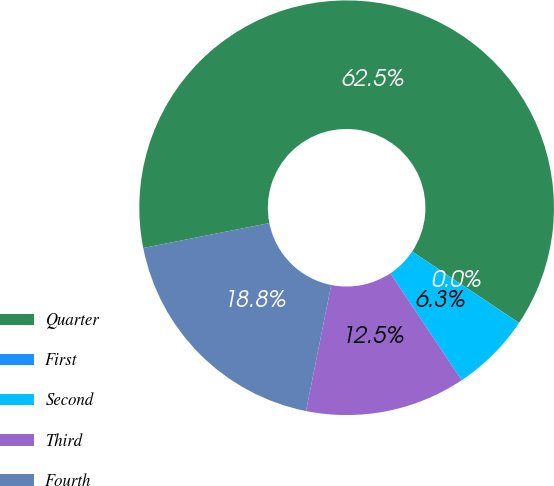<chart> <loc_0><loc_0><loc_500><loc_500><pie_chart><fcel>Quarter<fcel>First<fcel>Second<fcel>Third<fcel>Fourth<nl><fcel>62.48%<fcel>0.01%<fcel>6.26%<fcel>12.5%<fcel>18.75%<nl></chart> 